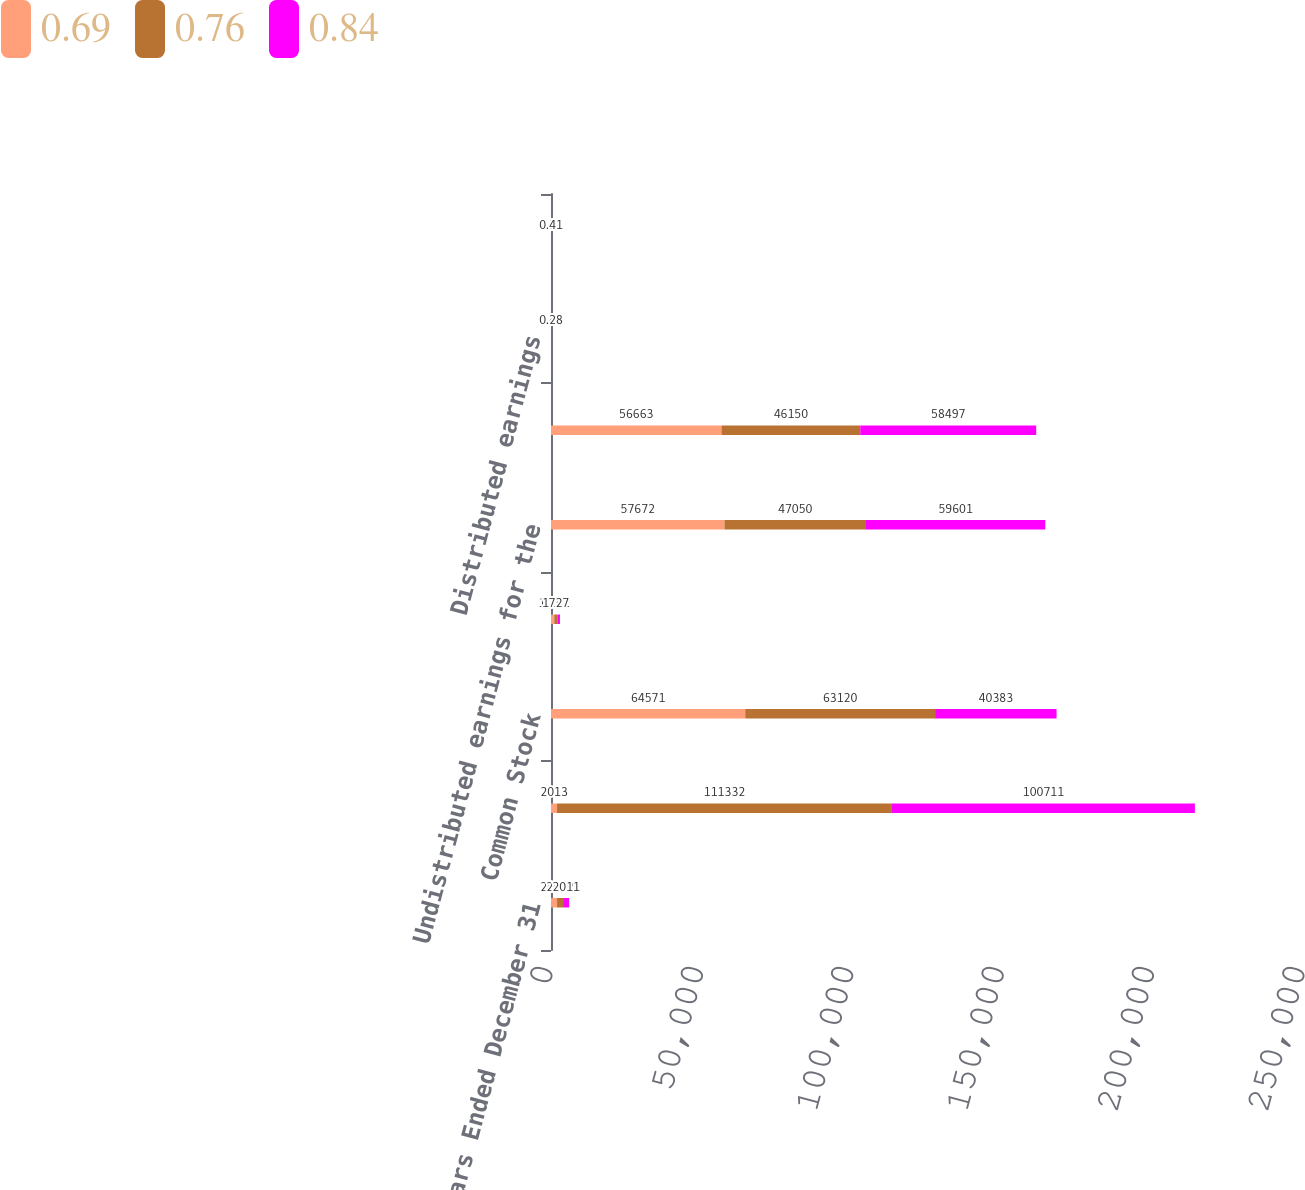Convert chart to OTSL. <chart><loc_0><loc_0><loc_500><loc_500><stacked_bar_chart><ecel><fcel>Years Ended December 31<fcel>Net Income<fcel>Common Stock<fcel>Restricted shares of common<fcel>Undistributed earnings for the<fcel>Common stock<fcel>Distributed earnings<fcel>Undistributed earnings<nl><fcel>0.69<fcel>2013<fcel>2013<fcel>64571<fcel>1087<fcel>57672<fcel>56663<fcel>0.45<fcel>0.39<nl><fcel>0.76<fcel>2012<fcel>111332<fcel>63120<fcel>1162<fcel>47050<fcel>46150<fcel>0.44<fcel>0.32<nl><fcel>0.84<fcel>2011<fcel>100711<fcel>40383<fcel>727<fcel>59601<fcel>58497<fcel>0.28<fcel>0.41<nl></chart> 